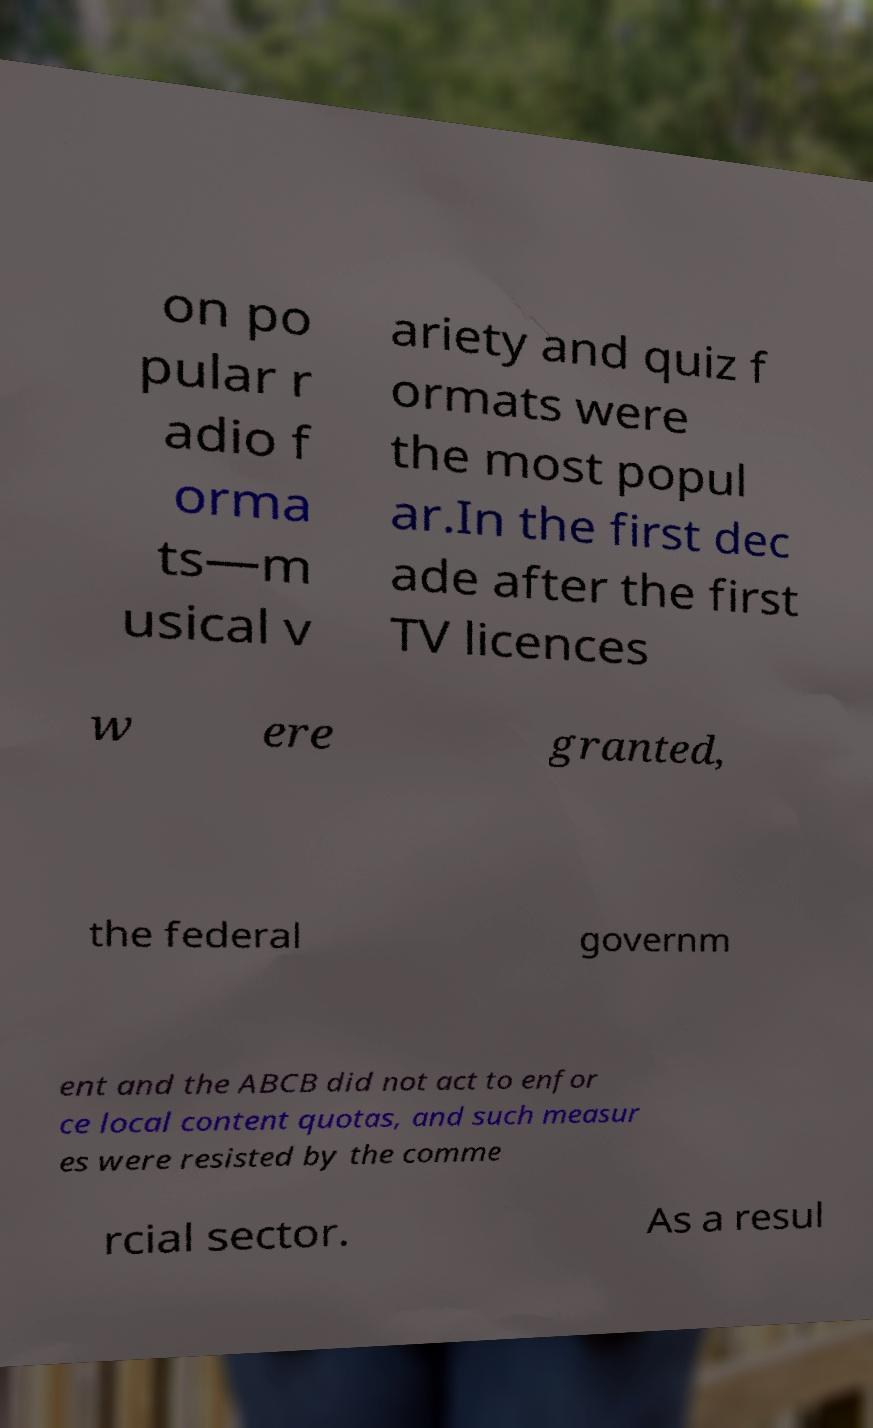Can you accurately transcribe the text from the provided image for me? on po pular r adio f orma ts—m usical v ariety and quiz f ormats were the most popul ar.In the first dec ade after the first TV licences w ere granted, the federal governm ent and the ABCB did not act to enfor ce local content quotas, and such measur es were resisted by the comme rcial sector. As a resul 